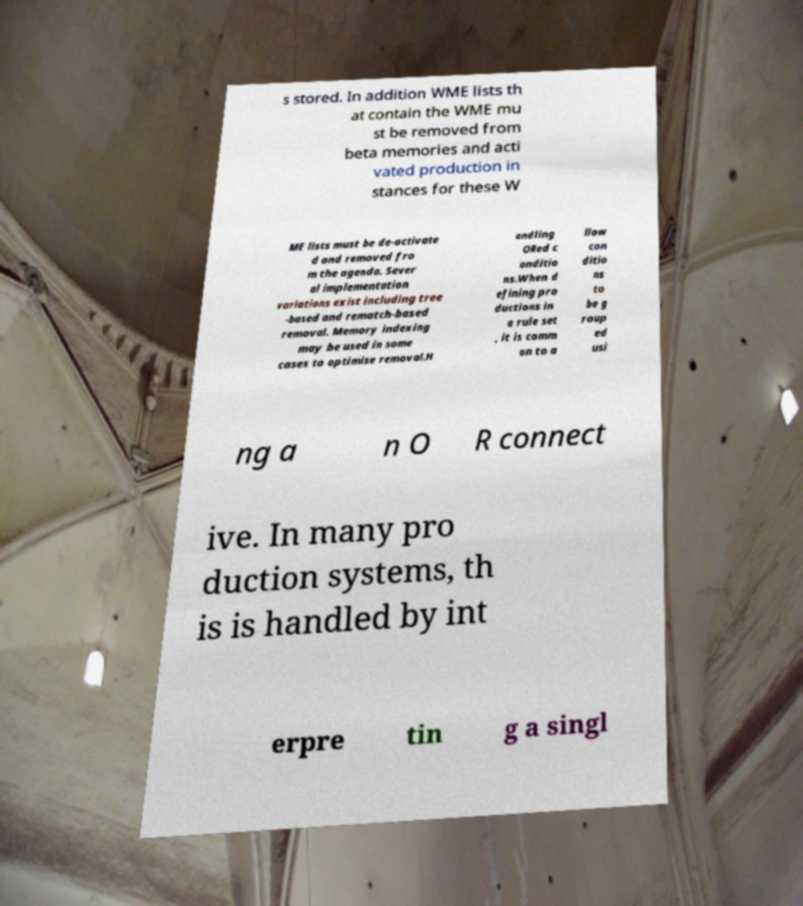Please read and relay the text visible in this image. What does it say? s stored. In addition WME lists th at contain the WME mu st be removed from beta memories and acti vated production in stances for these W ME lists must be de-activate d and removed fro m the agenda. Sever al implementation variations exist including tree -based and rematch-based removal. Memory indexing may be used in some cases to optimise removal.H andling ORed c onditio ns.When d efining pro ductions in a rule set , it is comm on to a llow con ditio ns to be g roup ed usi ng a n O R connect ive. In many pro duction systems, th is is handled by int erpre tin g a singl 